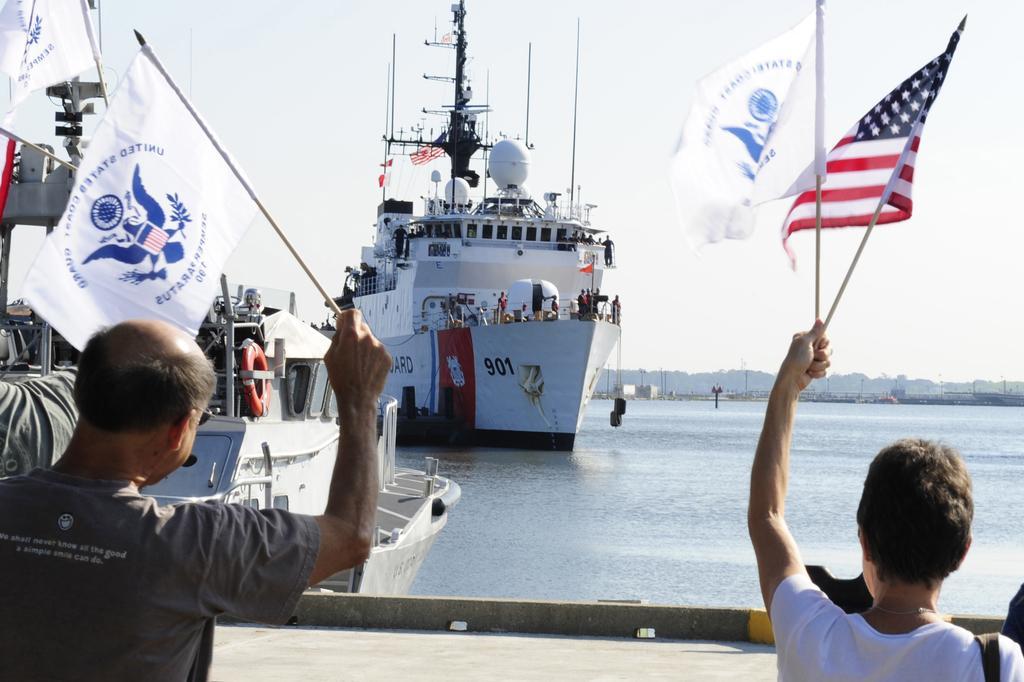Describe this image in one or two sentences. In this picture, we can see a few people, and among them a few are holding some objects like flag, and we can see path, boat some objects attached to the boat, and we can see ship and some objects attached to the ship like poles, we can see water, mountains and the sky. 